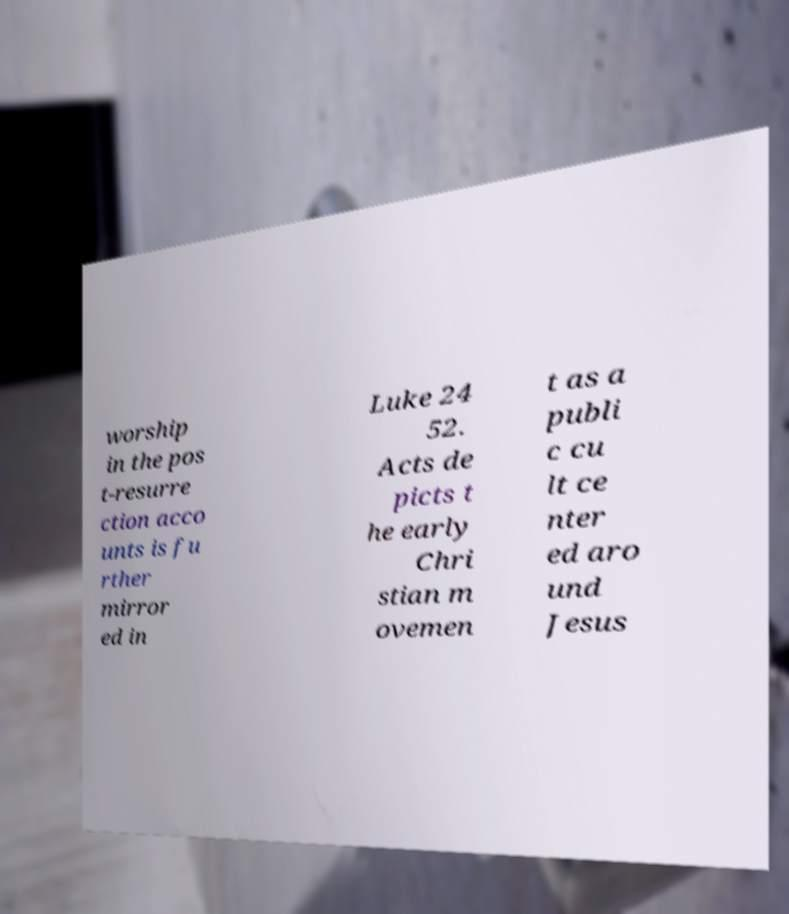There's text embedded in this image that I need extracted. Can you transcribe it verbatim? worship in the pos t-resurre ction acco unts is fu rther mirror ed in Luke 24 52. Acts de picts t he early Chri stian m ovemen t as a publi c cu lt ce nter ed aro und Jesus 